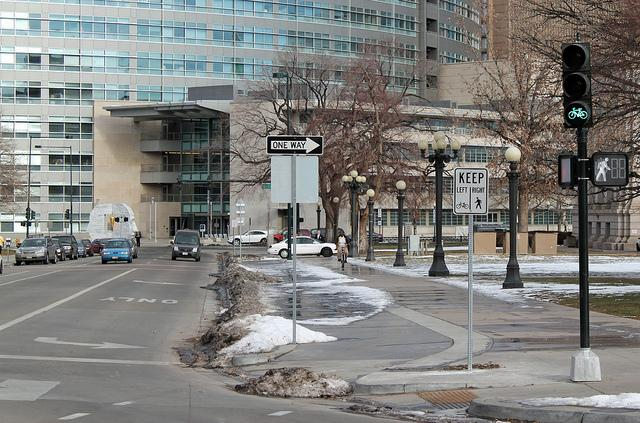What natural event seems to have occurred here? Please explain your reasoning. snow. The ground is partially covered by ice and a related substance that falls during winter. 